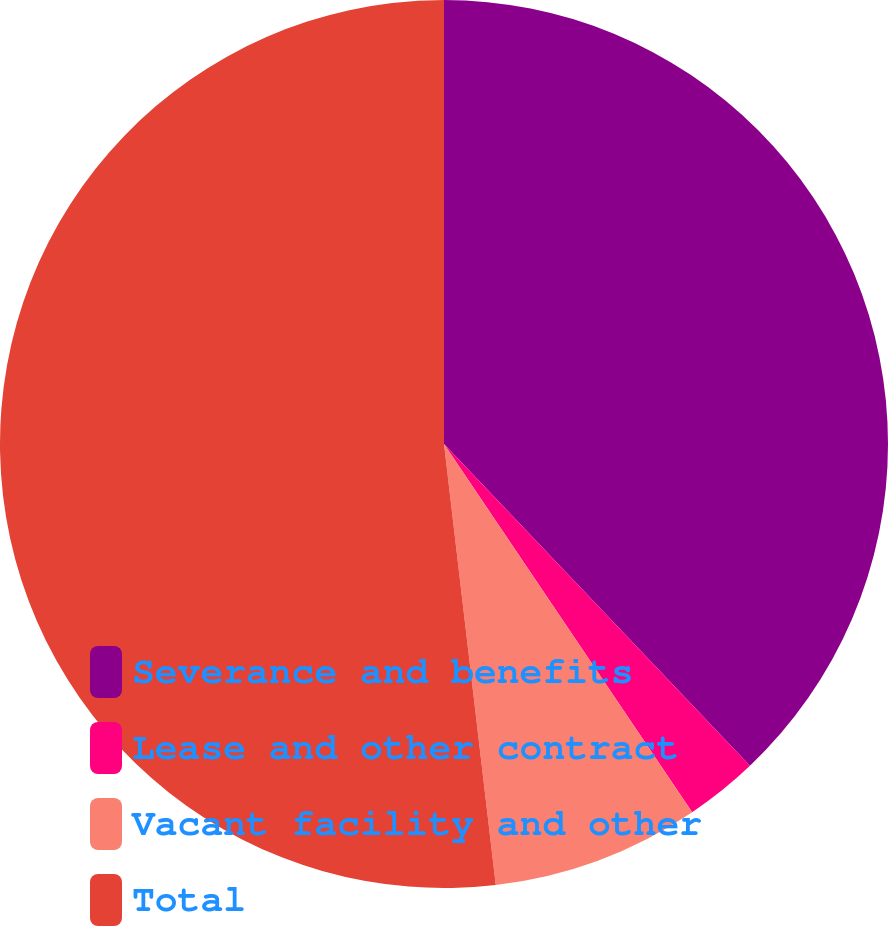Convert chart. <chart><loc_0><loc_0><loc_500><loc_500><pie_chart><fcel>Severance and benefits<fcel>Lease and other contract<fcel>Vacant facility and other<fcel>Total<nl><fcel>37.9%<fcel>2.66%<fcel>7.58%<fcel>51.86%<nl></chart> 